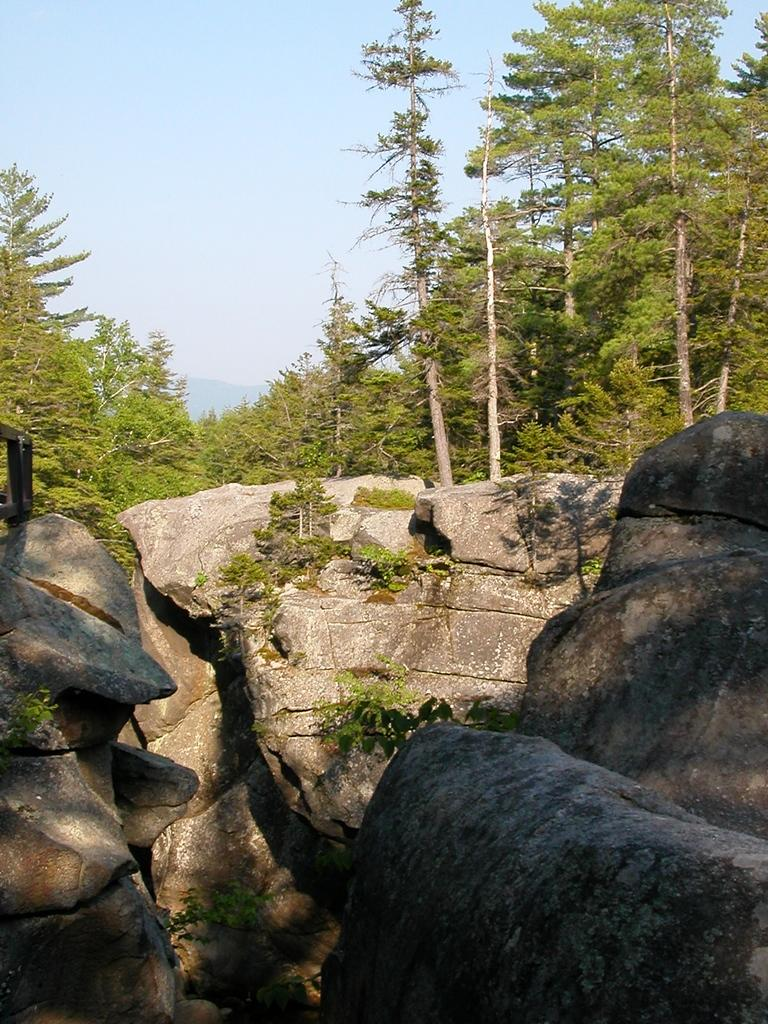What type of natural elements can be seen in the image? There are rocks, plants, and trees in the image. What part of the natural environment is visible in the image? The sky is visible in the image. Can you describe the vegetation present in the image? The image contains plants and trees. What type of waves can be seen crashing against the rocks in the image? There are no waves present in the image; it features rocks, plants, trees, and the sky. 